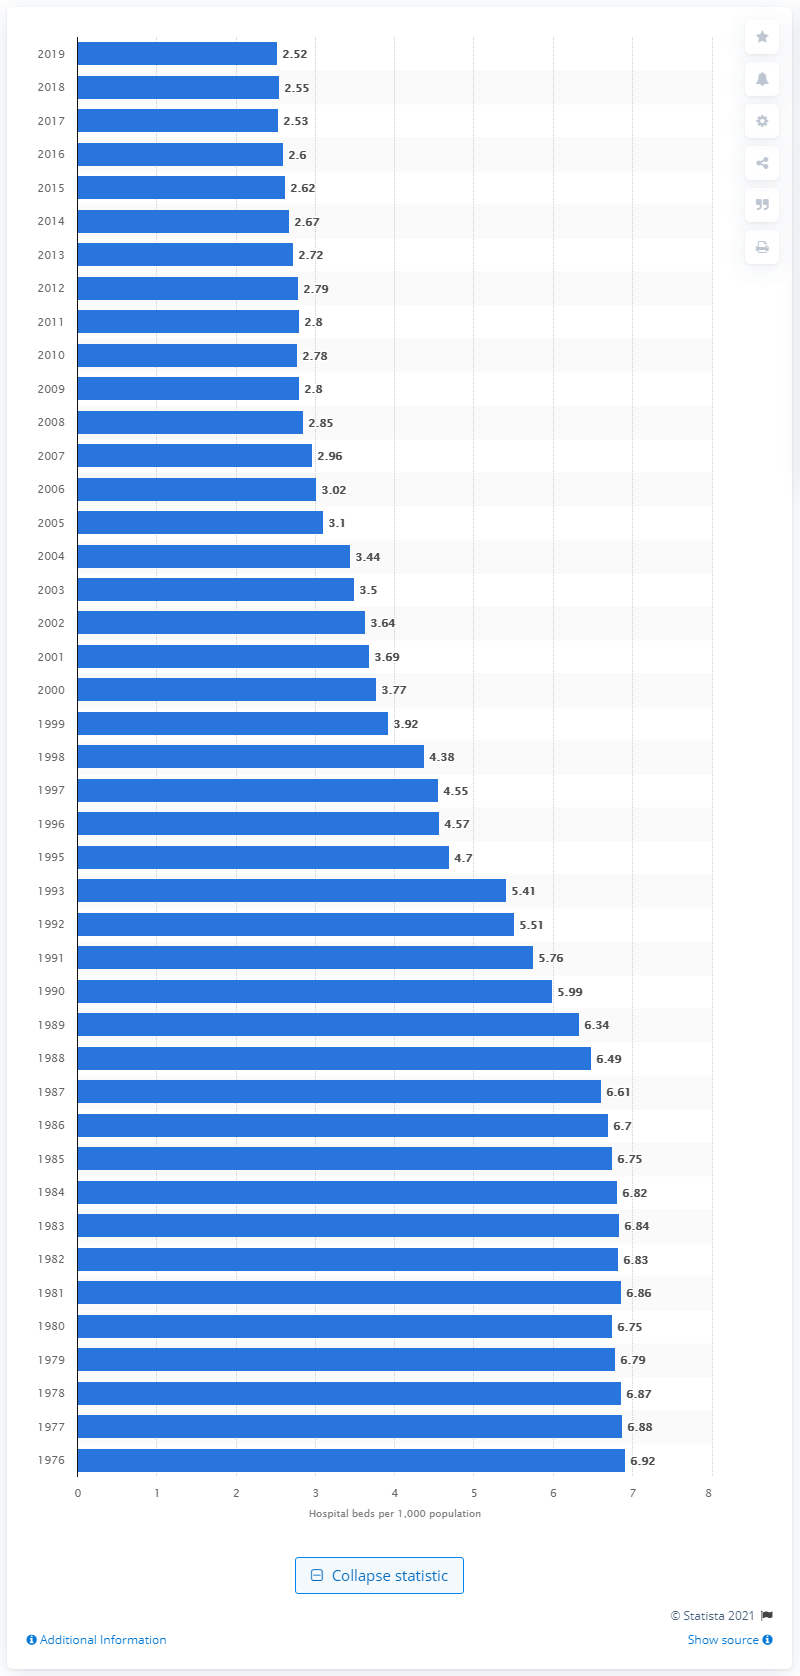Outline some significant characteristics in this image. In 1980, the average number of hospital beds per one thousand inhabitants in Canada was 6.75. 